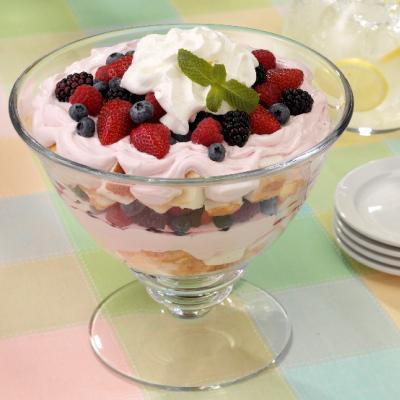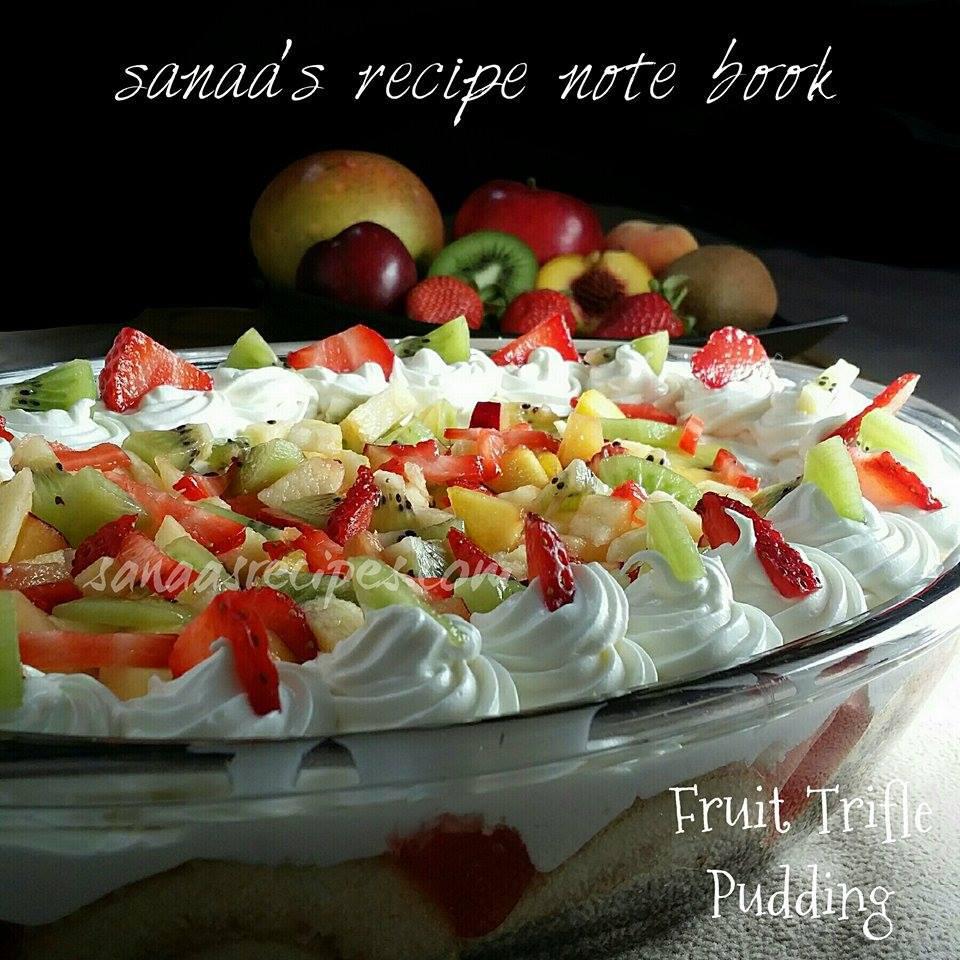The first image is the image on the left, the second image is the image on the right. Considering the images on both sides, is "The left image features a trifle garnished with thin apple slices." valid? Answer yes or no. No. 